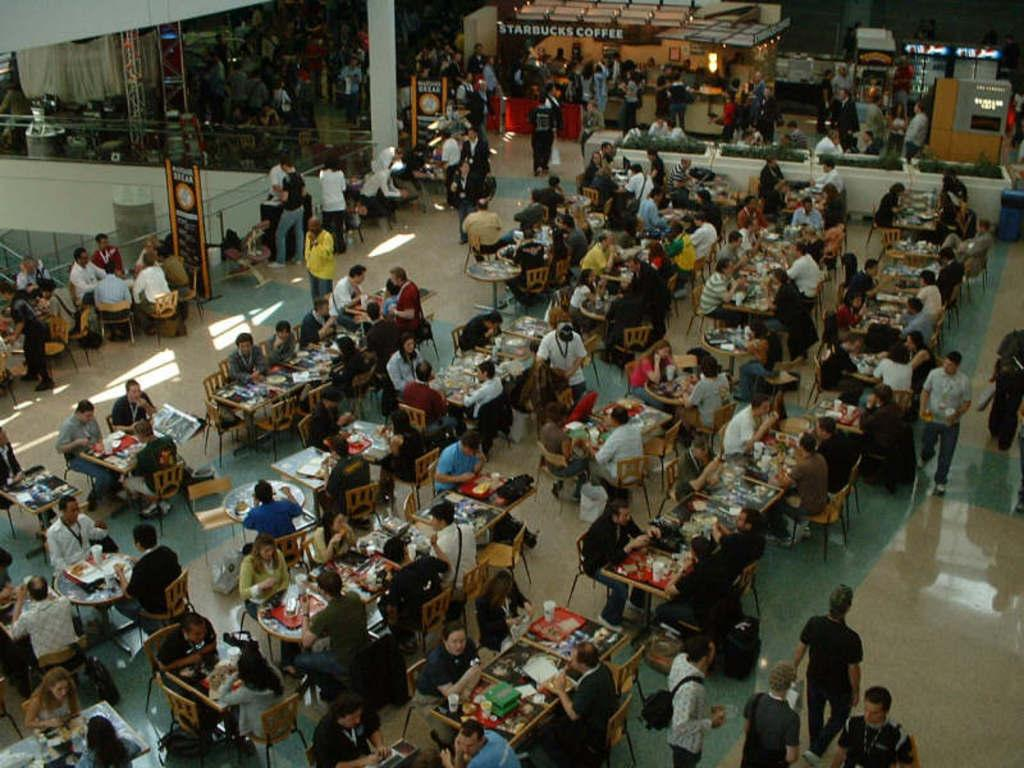What type of establishment is depicted in the image? The image shows the view of a restaurant. What are the people in the restaurant doing? There are men and women sitting and eating food in the restaurant. Can you identify any other businesses or establishments in the background? Yes, there is a Starbucks coffee shop visible in the background. What type of cheese is being served at the roof of the restaurant in the image? There is no cheese or roof visible in the image; it shows the view of a restaurant with people sitting and eating food, and a Starbucks coffee shop in the background. --- Facts: 1. There is a person standing on a bridge in the image. 2. The person is holding a camera. 3. The bridge is over a river. 4. There are trees on both sides of the river. Absurd Topics: bicycle, parrot, sand Conversation: What is the person in the image doing? The person is standing on a bridge in the image. What is the person holding in the image? The person is holding a camera. What is the bridge crossing in the image? The bridge is over a river. What can be seen on both sides of the river? There are trees on both sides of the river. Reasoning: Let's think step by step in order to produce the conversation. We start by identifying the main subject of the image, which is a person standing on a bridge. Then, we describe what the person is holding, which is a camera. Next, we mention the location of the bridge, which is over a river. Finally, we describe the surrounding environment, noting that there are trees on both sides of the river. Absurd Question/Answer: Can you tell me how many bicycles are parked on the sand near the river in the image? There are no bicycles or sand visible in the image; it shows a person standing on a bridge over a river, with trees on both sides. 